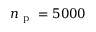<formula> <loc_0><loc_0><loc_500><loc_500>n _ { p } = 5 0 0 0</formula> 